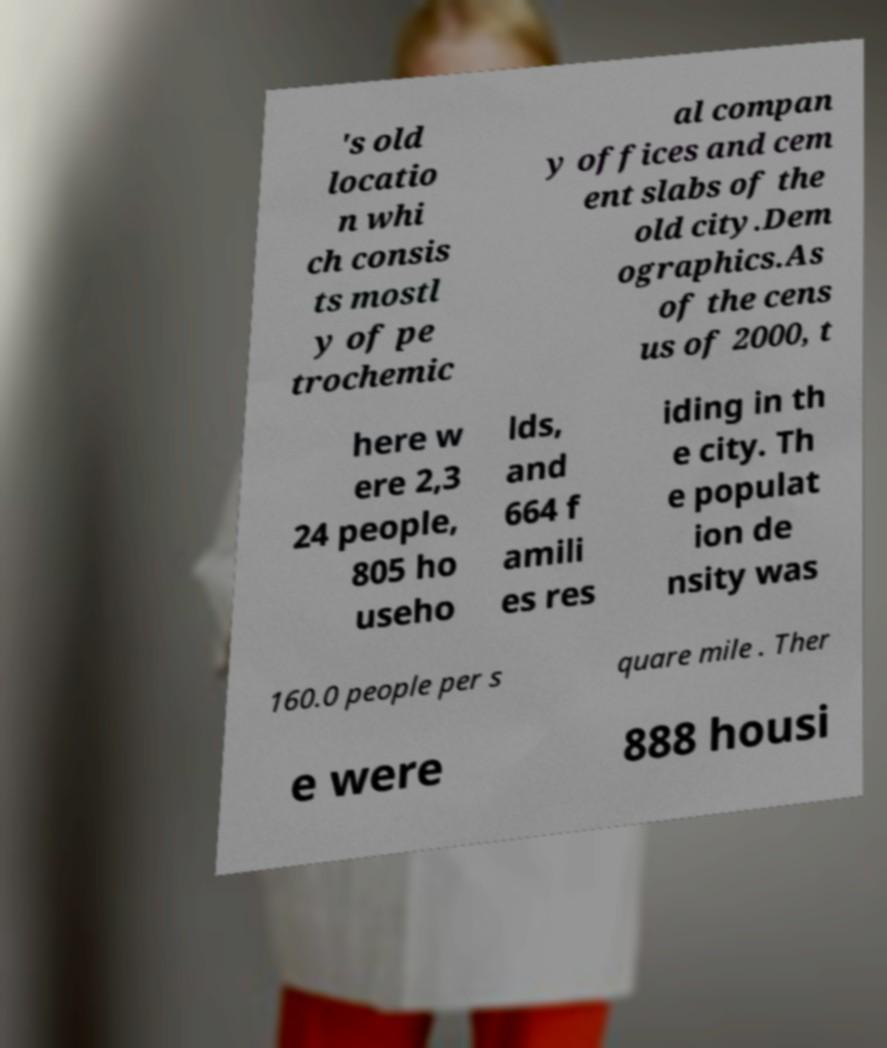For documentation purposes, I need the text within this image transcribed. Could you provide that? 's old locatio n whi ch consis ts mostl y of pe trochemic al compan y offices and cem ent slabs of the old city.Dem ographics.As of the cens us of 2000, t here w ere 2,3 24 people, 805 ho useho lds, and 664 f amili es res iding in th e city. Th e populat ion de nsity was 160.0 people per s quare mile . Ther e were 888 housi 